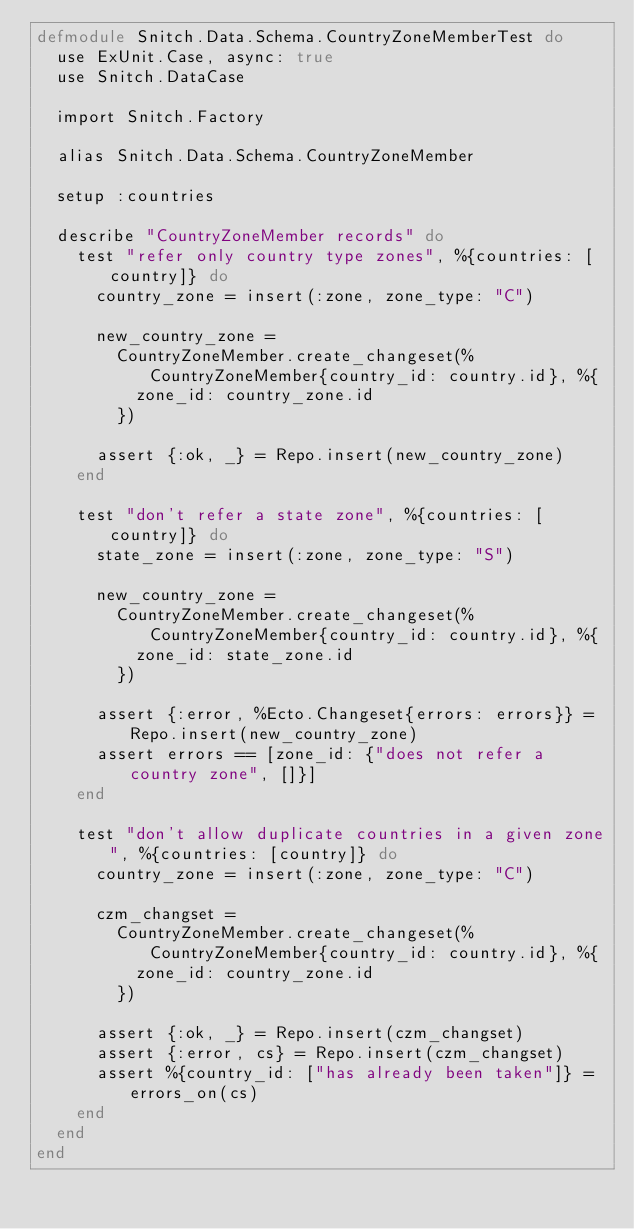Convert code to text. <code><loc_0><loc_0><loc_500><loc_500><_Elixir_>defmodule Snitch.Data.Schema.CountryZoneMemberTest do
  use ExUnit.Case, async: true
  use Snitch.DataCase

  import Snitch.Factory

  alias Snitch.Data.Schema.CountryZoneMember

  setup :countries

  describe "CountryZoneMember records" do
    test "refer only country type zones", %{countries: [country]} do
      country_zone = insert(:zone, zone_type: "C")

      new_country_zone =
        CountryZoneMember.create_changeset(%CountryZoneMember{country_id: country.id}, %{
          zone_id: country_zone.id
        })

      assert {:ok, _} = Repo.insert(new_country_zone)
    end

    test "don't refer a state zone", %{countries: [country]} do
      state_zone = insert(:zone, zone_type: "S")

      new_country_zone =
        CountryZoneMember.create_changeset(%CountryZoneMember{country_id: country.id}, %{
          zone_id: state_zone.id
        })

      assert {:error, %Ecto.Changeset{errors: errors}} = Repo.insert(new_country_zone)
      assert errors == [zone_id: {"does not refer a country zone", []}]
    end

    test "don't allow duplicate countries in a given zone", %{countries: [country]} do
      country_zone = insert(:zone, zone_type: "C")

      czm_changset =
        CountryZoneMember.create_changeset(%CountryZoneMember{country_id: country.id}, %{
          zone_id: country_zone.id
        })

      assert {:ok, _} = Repo.insert(czm_changset)
      assert {:error, cs} = Repo.insert(czm_changset)
      assert %{country_id: ["has already been taken"]} = errors_on(cs)
    end
  end
end
</code> 